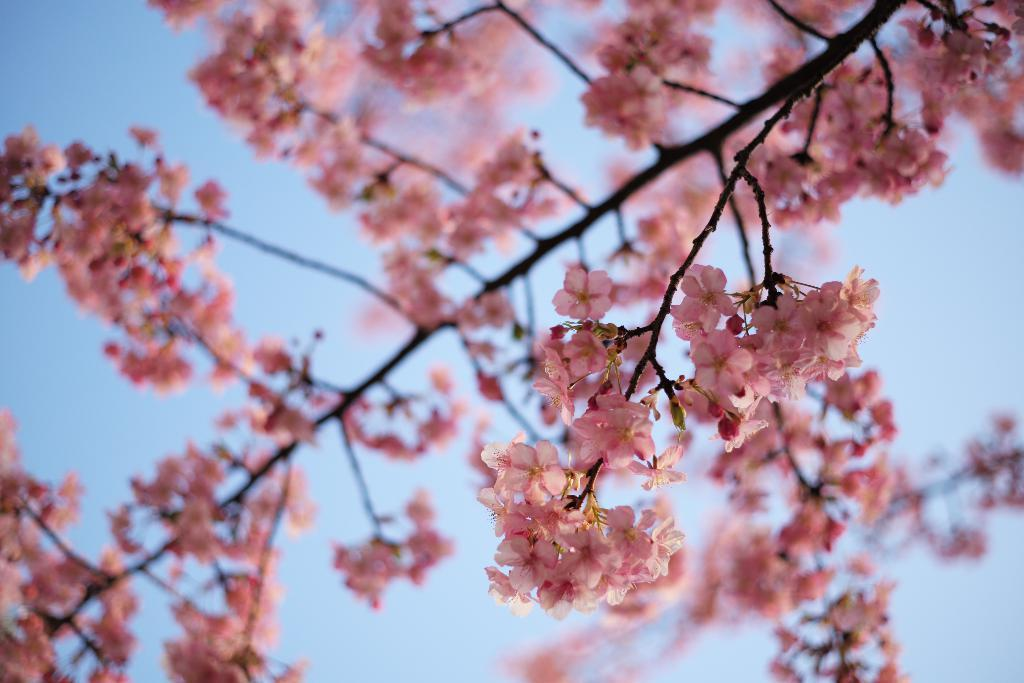What type of flora is present in the image? There are flowers in the image. What color are the flowers? The flowers are pink in color. Where are the flowers located in relation to other objects in the image? The flowers are near a tree. What can be seen in the background of the image? The sky is visible in the background of the image. How many ears can be seen on the flowers in the image? There are no ears present on the flowers in the image, as flowers do not have ears. 